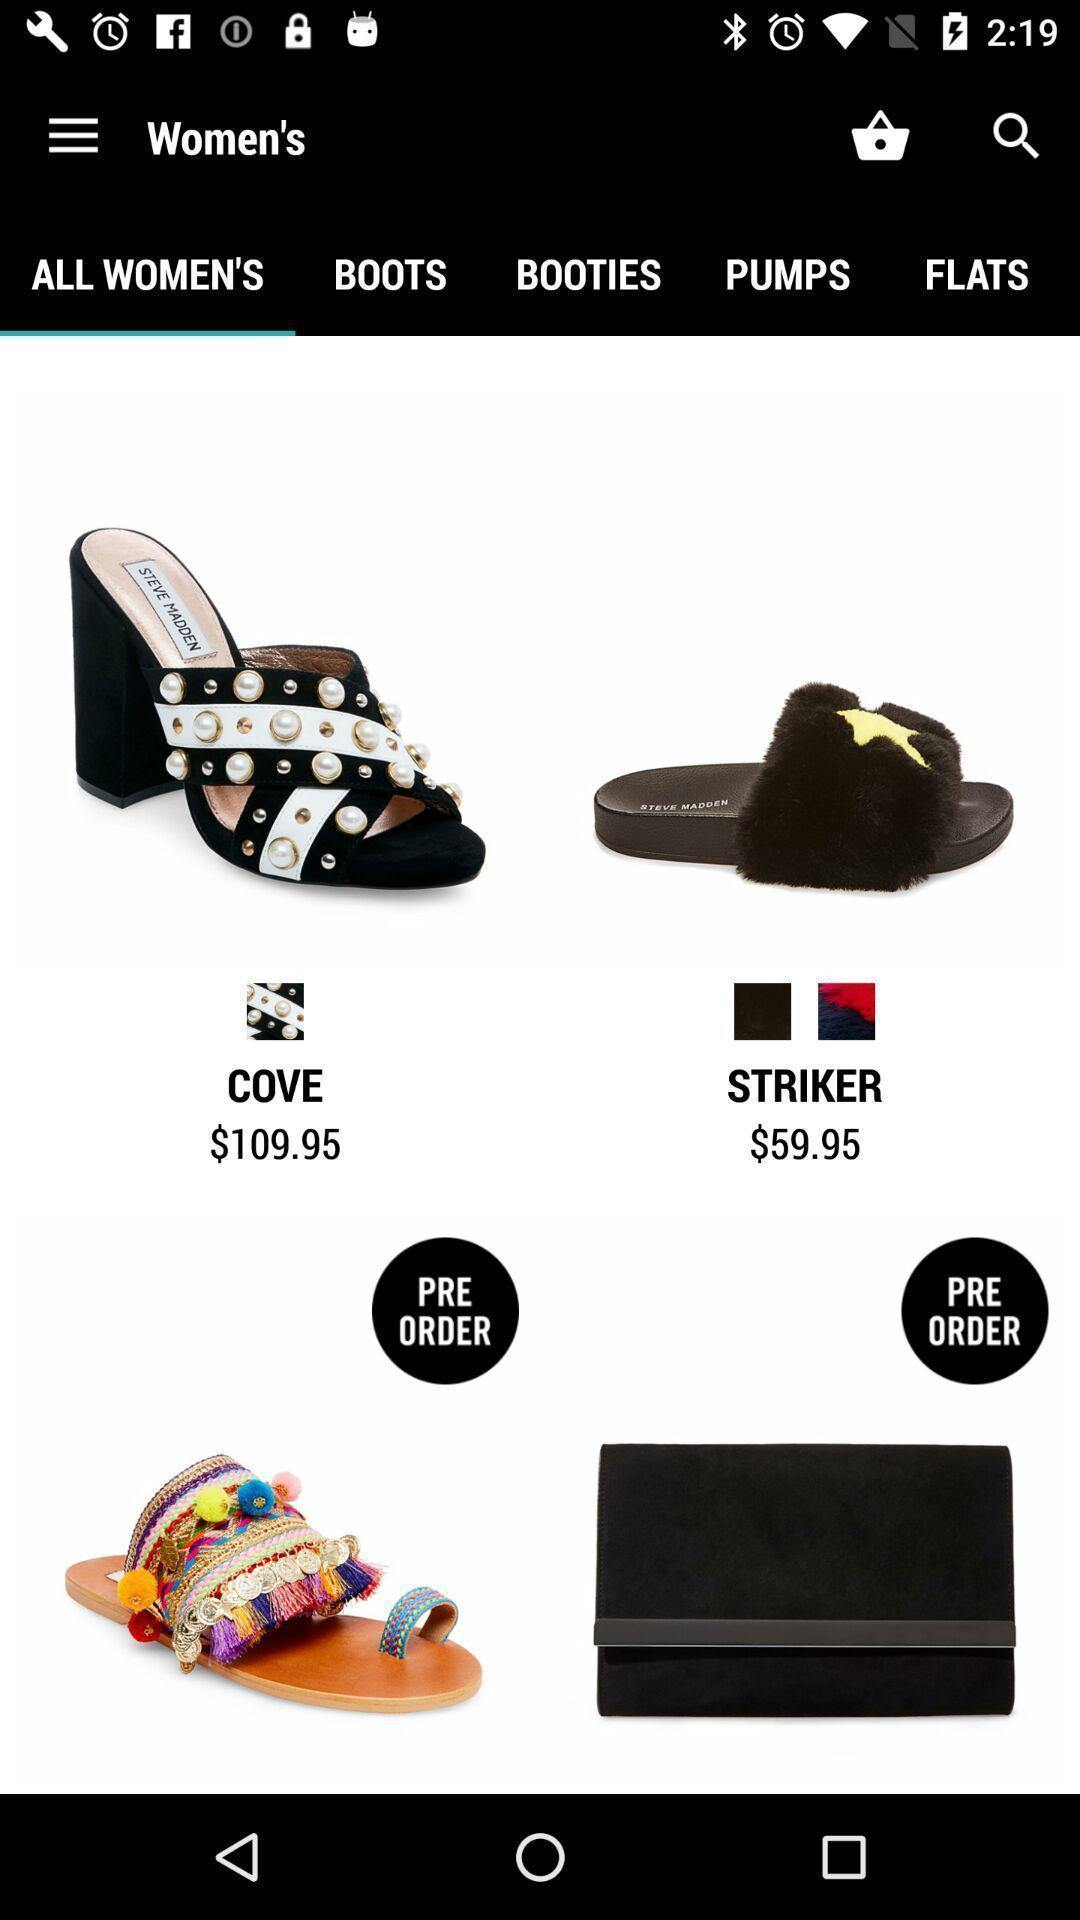Provide a detailed account of this screenshot. Screen displaying shopping page. 